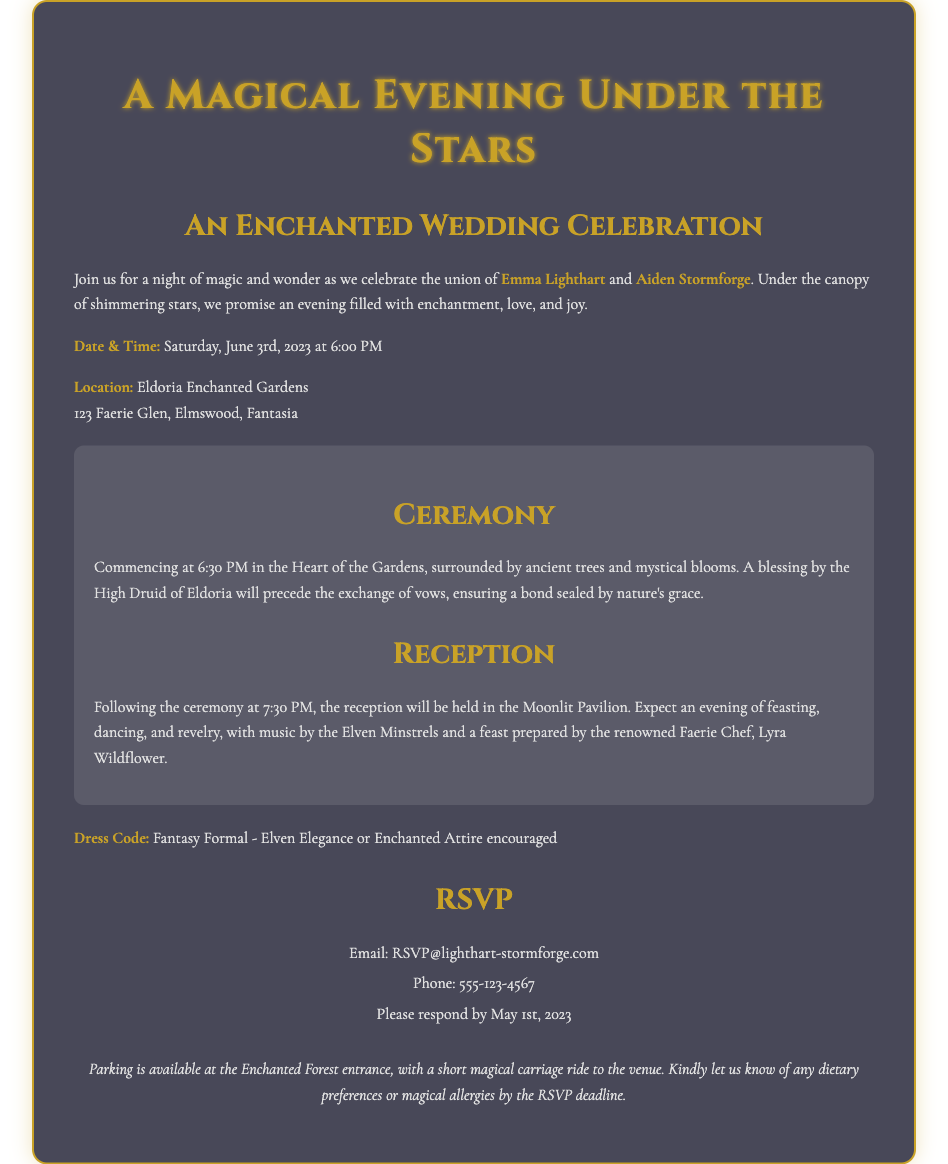What is the name of the bride? The document states that the bride's name is mentioned prominently in the invitation.
Answer: Emma Lighthart What is the date of the wedding? The date is clearly specified in the invitation, indicating when the event will take place.
Answer: Saturday, June 3rd, 2023 What is the dress code for the event? The invitation specifies a dress code that sets the tone for what guests should wear.
Answer: Fantasy Formal - Elven Elegance or Enchanted Attire encouraged Where is the wedding ceremony taking place? The location for the ceremony is provided in the invitation, giving a specific venue name.
Answer: Eldoria Enchanted Gardens What time does the reception start? The document mentions the schedule of events, including the start time for the reception.
Answer: 7:30 PM Who will bless the couple during the ceremony? The invitation includes details about the officiant, identifying who will perform the blessing.
Answer: High Druid of Eldoria What email should guests use to RSVP? The RSVP section provides a specific email address for response, essential for tracking attendees.
Answer: RSVP@lighthart-stormforge.com Why is there a note about dietary preferences? The invitation asks for dietary considerations, emphasizing the hosts' attention to guests' needs.
Answer: To accommodate dietary preferences or magical allergies 